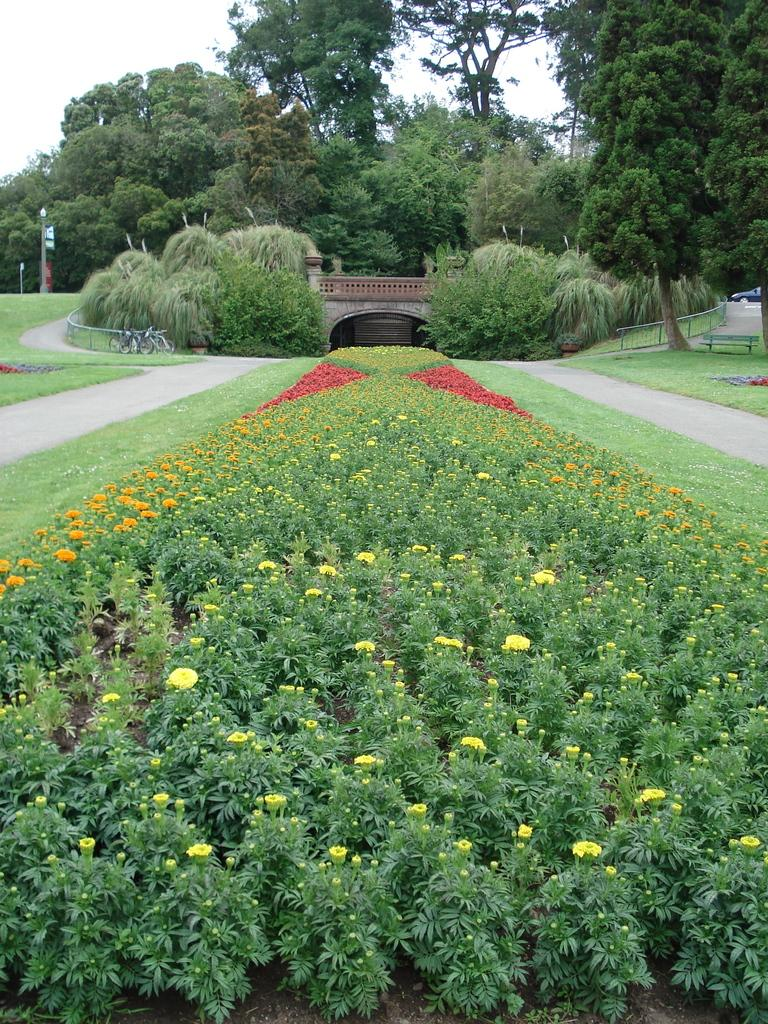What type of plants are present in the image? There are plants with flowers in the image. What type of structure can be seen in the image? There is a bridge in the image. What other vegetation is present in the image besides flowers? There are shrubs and trees in the image. What type of barrier is present in the image? There is a fence in the image. What type of ground cover is present in the image? There is grass in the image. What material is the bridge made of? The bridge is made of wood. What other objects are present in the image? There are poles and a car in the image. What can be seen in the background of the image? The sky is visible in the background of the image. What type of cap is the car wearing in the image? There is no cap present in the image; it is a car, not a person. What type of crook can be seen leaning on the fence in the image? There is no crook present in the image; it is a fence, not a person or character. 